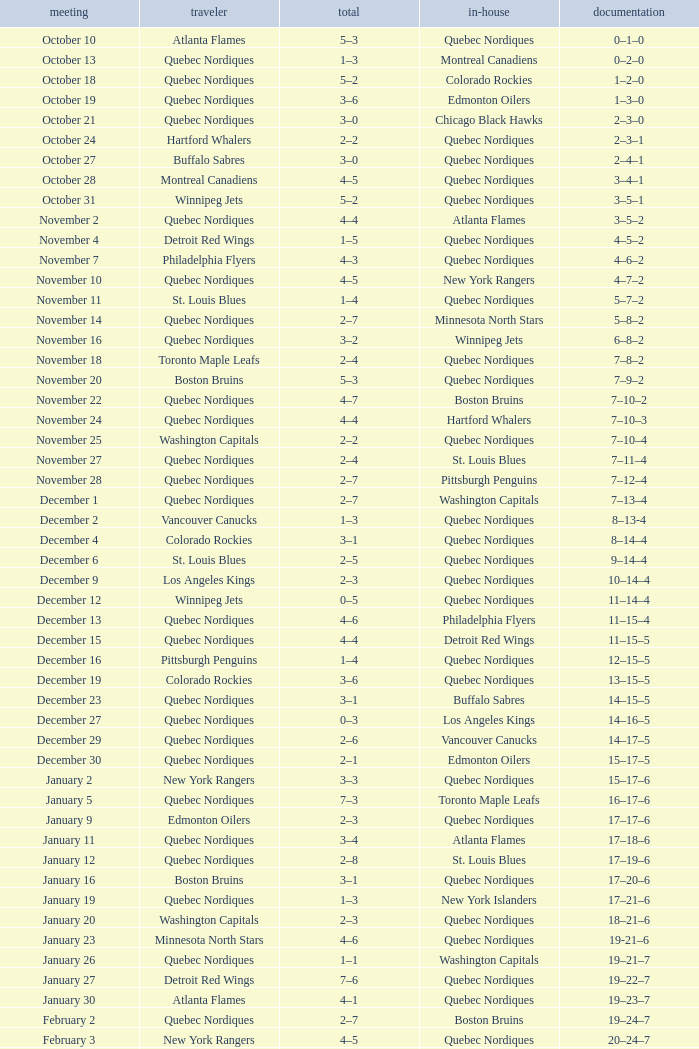Which Date has a Score of 2–7, and a Record of 5–8–2? November 14. 